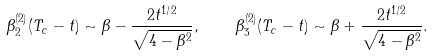<formula> <loc_0><loc_0><loc_500><loc_500>\beta _ { 2 } ^ { ( 2 ) } ( T _ { c } - t ) \sim \beta - \frac { 2 t ^ { 1 / 2 } } { \sqrt { 4 - \beta ^ { 2 } } } , \quad \beta _ { 3 } ^ { ( 2 ) } ( T _ { c } - t ) \sim \beta + \frac { 2 t ^ { 1 / 2 } } { \sqrt { 4 - \beta ^ { 2 } } } .</formula> 